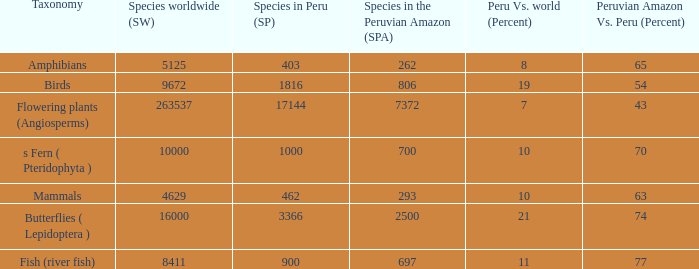What's the minimum species in the peruvian amazon with species in peru of 1000 700.0. 